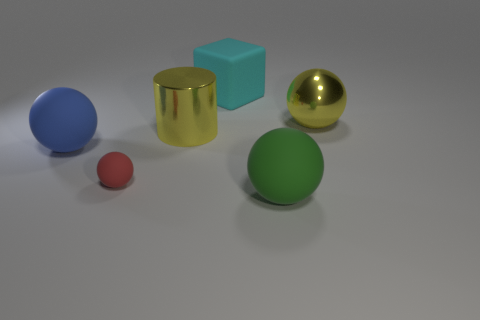What is the color of the block that is made of the same material as the red ball?
Give a very brief answer. Cyan. Is the red sphere made of the same material as the big cube?
Give a very brief answer. Yes. There is a cyan thing that is made of the same material as the large blue thing; what is its shape?
Your answer should be compact. Cube. What is the large sphere that is to the right of the large blue rubber object and behind the green ball made of?
Your response must be concise. Metal. What size is the metal thing behind the yellow cylinder that is left of the matte thing behind the big cylinder?
Your answer should be very brief. Large. Is the shape of the big blue rubber thing the same as the big matte object in front of the small red thing?
Make the answer very short. Yes. What number of big matte objects are both on the right side of the small red sphere and on the left side of the large green object?
Keep it short and to the point. 1. Does the large metallic object that is to the right of the green ball have the same color as the rubber thing right of the large cyan block?
Your response must be concise. No. There is a large block that is to the right of the yellow metallic thing that is left of the thing in front of the tiny sphere; what color is it?
Your answer should be very brief. Cyan. There is a large yellow shiny object right of the green object; are there any big cyan rubber objects that are in front of it?
Make the answer very short. No. 